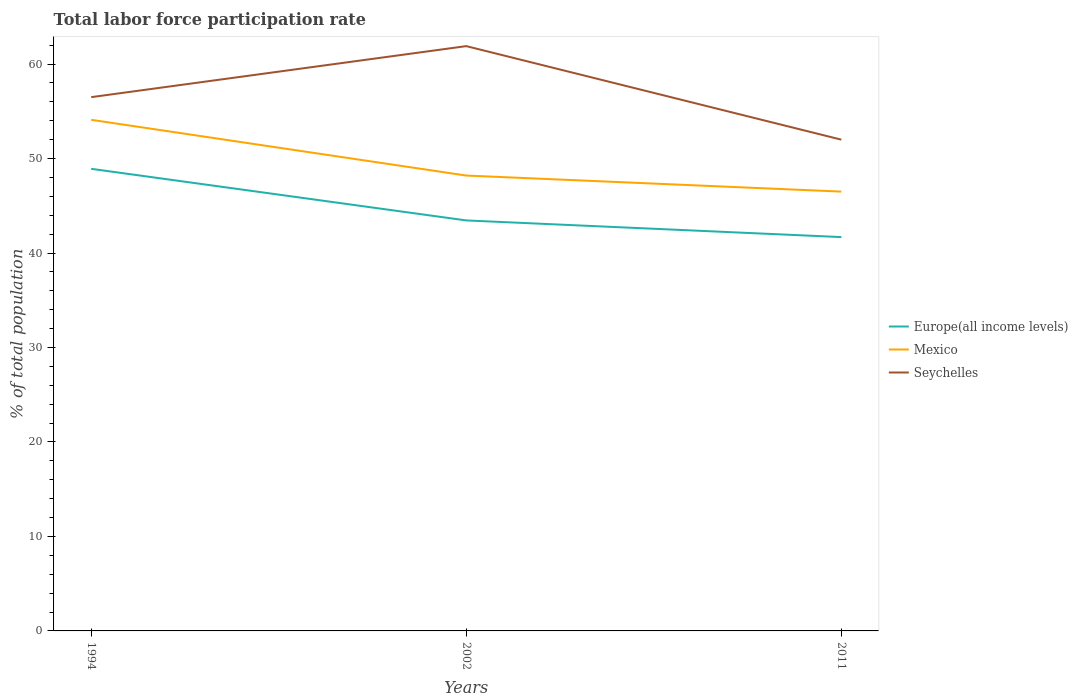Does the line corresponding to Europe(all income levels) intersect with the line corresponding to Mexico?
Offer a very short reply. No. In which year was the total labor force participation rate in Mexico maximum?
Give a very brief answer. 2011. What is the total total labor force participation rate in Europe(all income levels) in the graph?
Give a very brief answer. 7.23. What is the difference between the highest and the second highest total labor force participation rate in Seychelles?
Offer a terse response. 9.9. What is the difference between the highest and the lowest total labor force participation rate in Mexico?
Give a very brief answer. 1. How many lines are there?
Give a very brief answer. 3. How many years are there in the graph?
Offer a terse response. 3. Are the values on the major ticks of Y-axis written in scientific E-notation?
Provide a short and direct response. No. How many legend labels are there?
Your answer should be very brief. 3. What is the title of the graph?
Keep it short and to the point. Total labor force participation rate. What is the label or title of the X-axis?
Offer a terse response. Years. What is the label or title of the Y-axis?
Your answer should be compact. % of total population. What is the % of total population of Europe(all income levels) in 1994?
Your answer should be very brief. 48.91. What is the % of total population in Mexico in 1994?
Offer a terse response. 54.1. What is the % of total population of Seychelles in 1994?
Keep it short and to the point. 56.5. What is the % of total population in Europe(all income levels) in 2002?
Offer a terse response. 43.45. What is the % of total population in Mexico in 2002?
Your answer should be very brief. 48.2. What is the % of total population in Seychelles in 2002?
Your answer should be very brief. 61.9. What is the % of total population in Europe(all income levels) in 2011?
Your answer should be compact. 41.69. What is the % of total population in Mexico in 2011?
Ensure brevity in your answer.  46.5. Across all years, what is the maximum % of total population of Europe(all income levels)?
Give a very brief answer. 48.91. Across all years, what is the maximum % of total population of Mexico?
Offer a terse response. 54.1. Across all years, what is the maximum % of total population in Seychelles?
Your answer should be very brief. 61.9. Across all years, what is the minimum % of total population of Europe(all income levels)?
Provide a short and direct response. 41.69. Across all years, what is the minimum % of total population in Mexico?
Make the answer very short. 46.5. Across all years, what is the minimum % of total population in Seychelles?
Your answer should be compact. 52. What is the total % of total population of Europe(all income levels) in the graph?
Your answer should be compact. 134.05. What is the total % of total population of Mexico in the graph?
Make the answer very short. 148.8. What is the total % of total population in Seychelles in the graph?
Offer a very short reply. 170.4. What is the difference between the % of total population in Europe(all income levels) in 1994 and that in 2002?
Provide a short and direct response. 5.46. What is the difference between the % of total population in Europe(all income levels) in 1994 and that in 2011?
Ensure brevity in your answer.  7.23. What is the difference between the % of total population in Seychelles in 1994 and that in 2011?
Provide a short and direct response. 4.5. What is the difference between the % of total population of Europe(all income levels) in 2002 and that in 2011?
Keep it short and to the point. 1.76. What is the difference between the % of total population in Seychelles in 2002 and that in 2011?
Your response must be concise. 9.9. What is the difference between the % of total population in Europe(all income levels) in 1994 and the % of total population in Mexico in 2002?
Ensure brevity in your answer.  0.71. What is the difference between the % of total population of Europe(all income levels) in 1994 and the % of total population of Seychelles in 2002?
Offer a terse response. -12.99. What is the difference between the % of total population of Europe(all income levels) in 1994 and the % of total population of Mexico in 2011?
Make the answer very short. 2.41. What is the difference between the % of total population in Europe(all income levels) in 1994 and the % of total population in Seychelles in 2011?
Give a very brief answer. -3.09. What is the difference between the % of total population in Mexico in 1994 and the % of total population in Seychelles in 2011?
Ensure brevity in your answer.  2.1. What is the difference between the % of total population of Europe(all income levels) in 2002 and the % of total population of Mexico in 2011?
Your response must be concise. -3.05. What is the difference between the % of total population in Europe(all income levels) in 2002 and the % of total population in Seychelles in 2011?
Your answer should be very brief. -8.55. What is the average % of total population of Europe(all income levels) per year?
Keep it short and to the point. 44.68. What is the average % of total population in Mexico per year?
Offer a terse response. 49.6. What is the average % of total population of Seychelles per year?
Offer a terse response. 56.8. In the year 1994, what is the difference between the % of total population in Europe(all income levels) and % of total population in Mexico?
Provide a succinct answer. -5.19. In the year 1994, what is the difference between the % of total population of Europe(all income levels) and % of total population of Seychelles?
Provide a short and direct response. -7.59. In the year 2002, what is the difference between the % of total population in Europe(all income levels) and % of total population in Mexico?
Provide a succinct answer. -4.75. In the year 2002, what is the difference between the % of total population in Europe(all income levels) and % of total population in Seychelles?
Offer a terse response. -18.45. In the year 2002, what is the difference between the % of total population of Mexico and % of total population of Seychelles?
Offer a terse response. -13.7. In the year 2011, what is the difference between the % of total population in Europe(all income levels) and % of total population in Mexico?
Give a very brief answer. -4.81. In the year 2011, what is the difference between the % of total population in Europe(all income levels) and % of total population in Seychelles?
Ensure brevity in your answer.  -10.31. In the year 2011, what is the difference between the % of total population of Mexico and % of total population of Seychelles?
Make the answer very short. -5.5. What is the ratio of the % of total population in Europe(all income levels) in 1994 to that in 2002?
Your answer should be very brief. 1.13. What is the ratio of the % of total population of Mexico in 1994 to that in 2002?
Make the answer very short. 1.12. What is the ratio of the % of total population in Seychelles in 1994 to that in 2002?
Your response must be concise. 0.91. What is the ratio of the % of total population in Europe(all income levels) in 1994 to that in 2011?
Your answer should be compact. 1.17. What is the ratio of the % of total population of Mexico in 1994 to that in 2011?
Your answer should be compact. 1.16. What is the ratio of the % of total population of Seychelles in 1994 to that in 2011?
Offer a terse response. 1.09. What is the ratio of the % of total population of Europe(all income levels) in 2002 to that in 2011?
Offer a very short reply. 1.04. What is the ratio of the % of total population in Mexico in 2002 to that in 2011?
Make the answer very short. 1.04. What is the ratio of the % of total population in Seychelles in 2002 to that in 2011?
Provide a short and direct response. 1.19. What is the difference between the highest and the second highest % of total population in Europe(all income levels)?
Give a very brief answer. 5.46. What is the difference between the highest and the second highest % of total population of Seychelles?
Give a very brief answer. 5.4. What is the difference between the highest and the lowest % of total population of Europe(all income levels)?
Offer a terse response. 7.23. What is the difference between the highest and the lowest % of total population in Seychelles?
Offer a terse response. 9.9. 